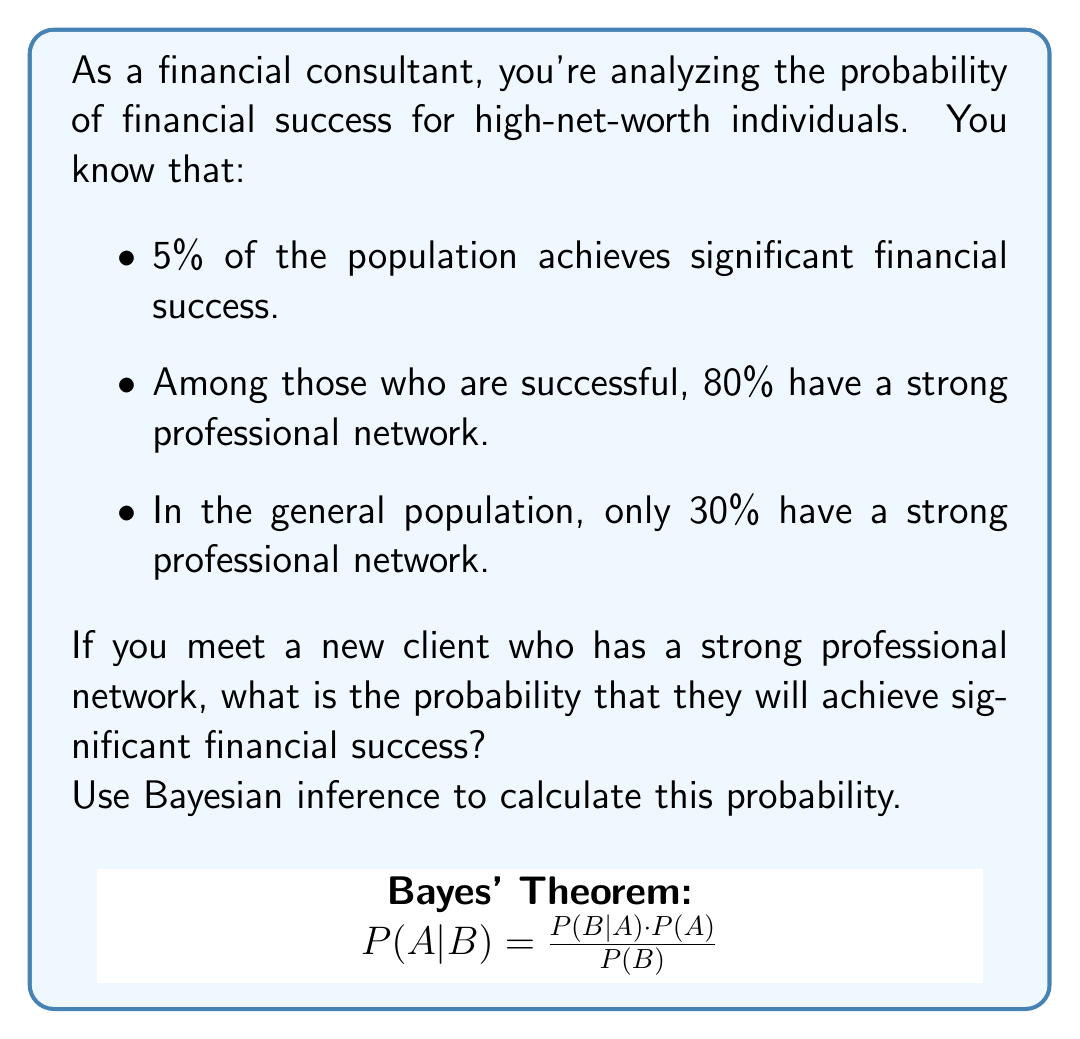Can you answer this question? Let's approach this step-by-step using Bayesian inference:

1) Define our events:
   S: Significant financial success
   N: Strong professional network

2) Given probabilities:
   P(S) = 0.05 (prior probability of success)
   P(N|S) = 0.80 (probability of strong network given success)
   P(N) = 0.30 (probability of strong network in general population)

3) We want to find P(S|N) using Bayes' theorem:

   $$P(S|N) = \frac{P(N|S) \cdot P(S)}{P(N)}$$

4) We have P(N|S) and P(S), but we need to calculate P(N):
   
   P(N) = P(N|S) · P(S) + P(N|not S) · P(not S)
   
   We know P(N|S) = 0.80 and P(S) = 0.05
   P(not S) = 1 - P(S) = 0.95
   
   We can find P(N|not S) using the law of total probability:
   0.30 = 0.80 · 0.05 + P(N|not S) · 0.95
   P(N|not S) = (0.30 - 0.04) / 0.95 ≈ 0.2737

5) Now we can calculate P(S|N):

   $$P(S|N) = \frac{0.80 \cdot 0.05}{0.30} \approx 0.1333$$

6) Convert to percentage: 0.1333 * 100 ≈ 13.33%
Answer: 13.33% 